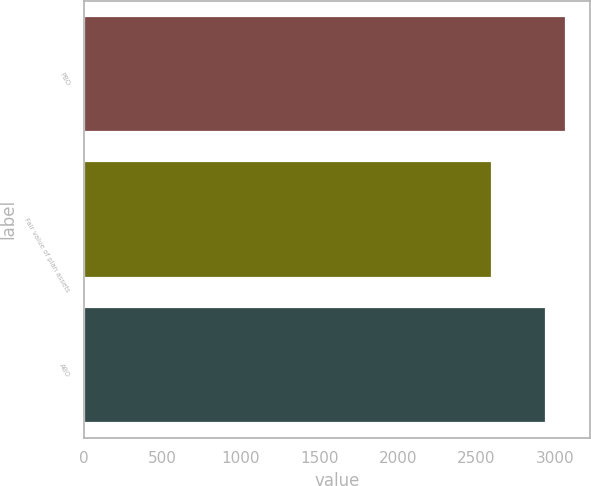Convert chart to OTSL. <chart><loc_0><loc_0><loc_500><loc_500><bar_chart><fcel>PBO<fcel>Fair value of plan assets<fcel>ABO<nl><fcel>3069.2<fcel>2602.8<fcel>2941.2<nl></chart> 